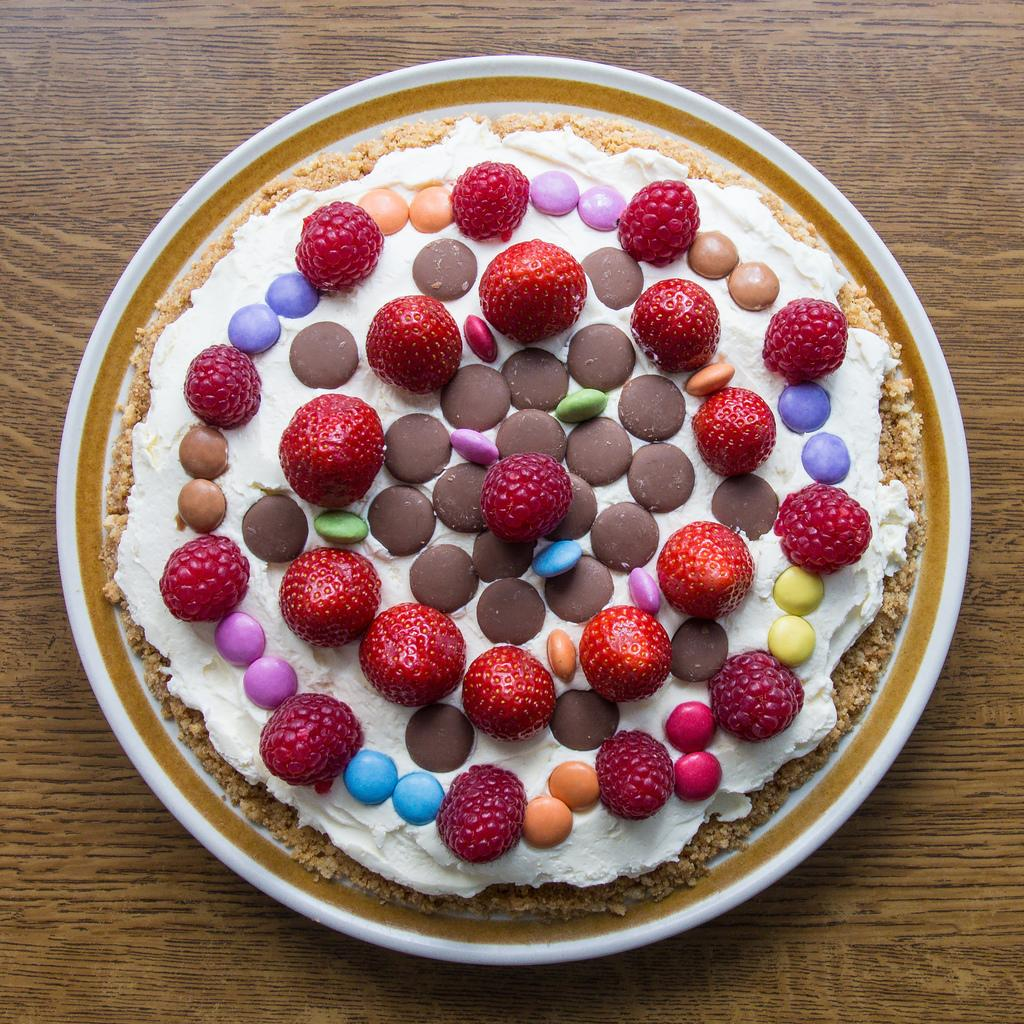What is on the plate that is visible in the image? The plate contains strawberries and gems. What type of vegetation is in the image? There is a tree in the image. Where is the plate placed in the image? The plate is placed on a wooden table. What type of box is being used to store the tree in the image? There is no box present in the image, and the tree is not being stored; it is a natural part of the scene. 